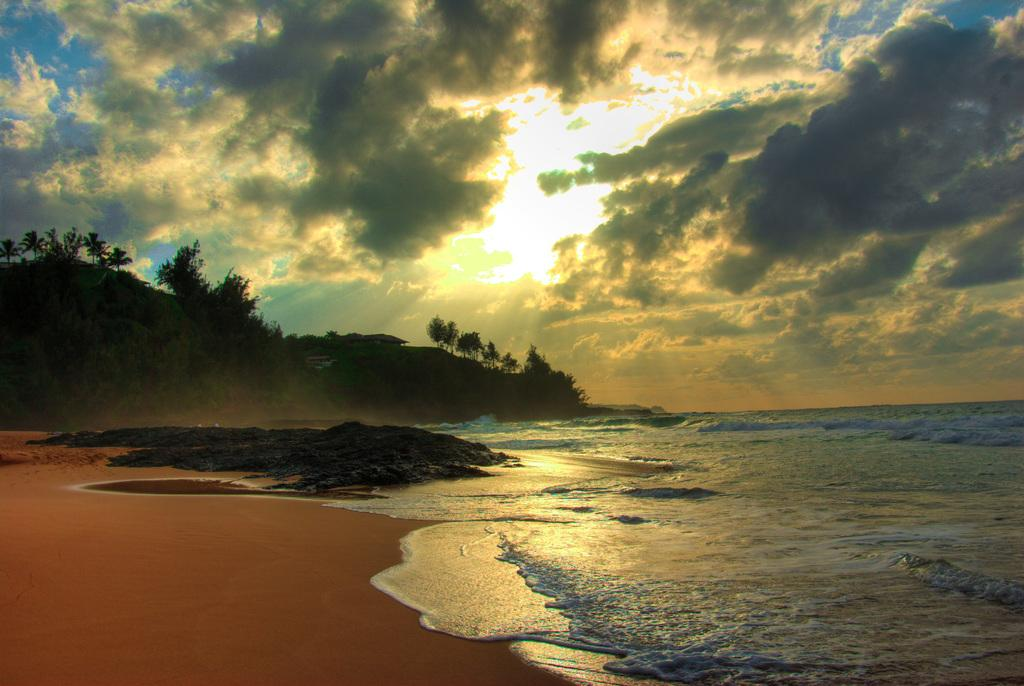What type of natural feature is depicted in the image? The image contains waves, water, sand, hills, trees, and sky, which are all elements of a natural landscape. What is the primary substance that makes up the waves and water in the image? The primary substance that makes up the waves and water in the image is water. What type of terrain can be seen in the image? The image contains sand, hills, and trees, which are all elements of a beach or coastal landscape. What is visible in the sky in the image? The sky in the image contains the sun, clouds, and a blue background. Can you describe the weather conditions in the image? The presence of clouds and the sun suggests that it is partly cloudy in the image. How many grains of salt can be seen on the trees in the image? There is no salt visible on the trees in the image, as salt is not a natural component of trees. 